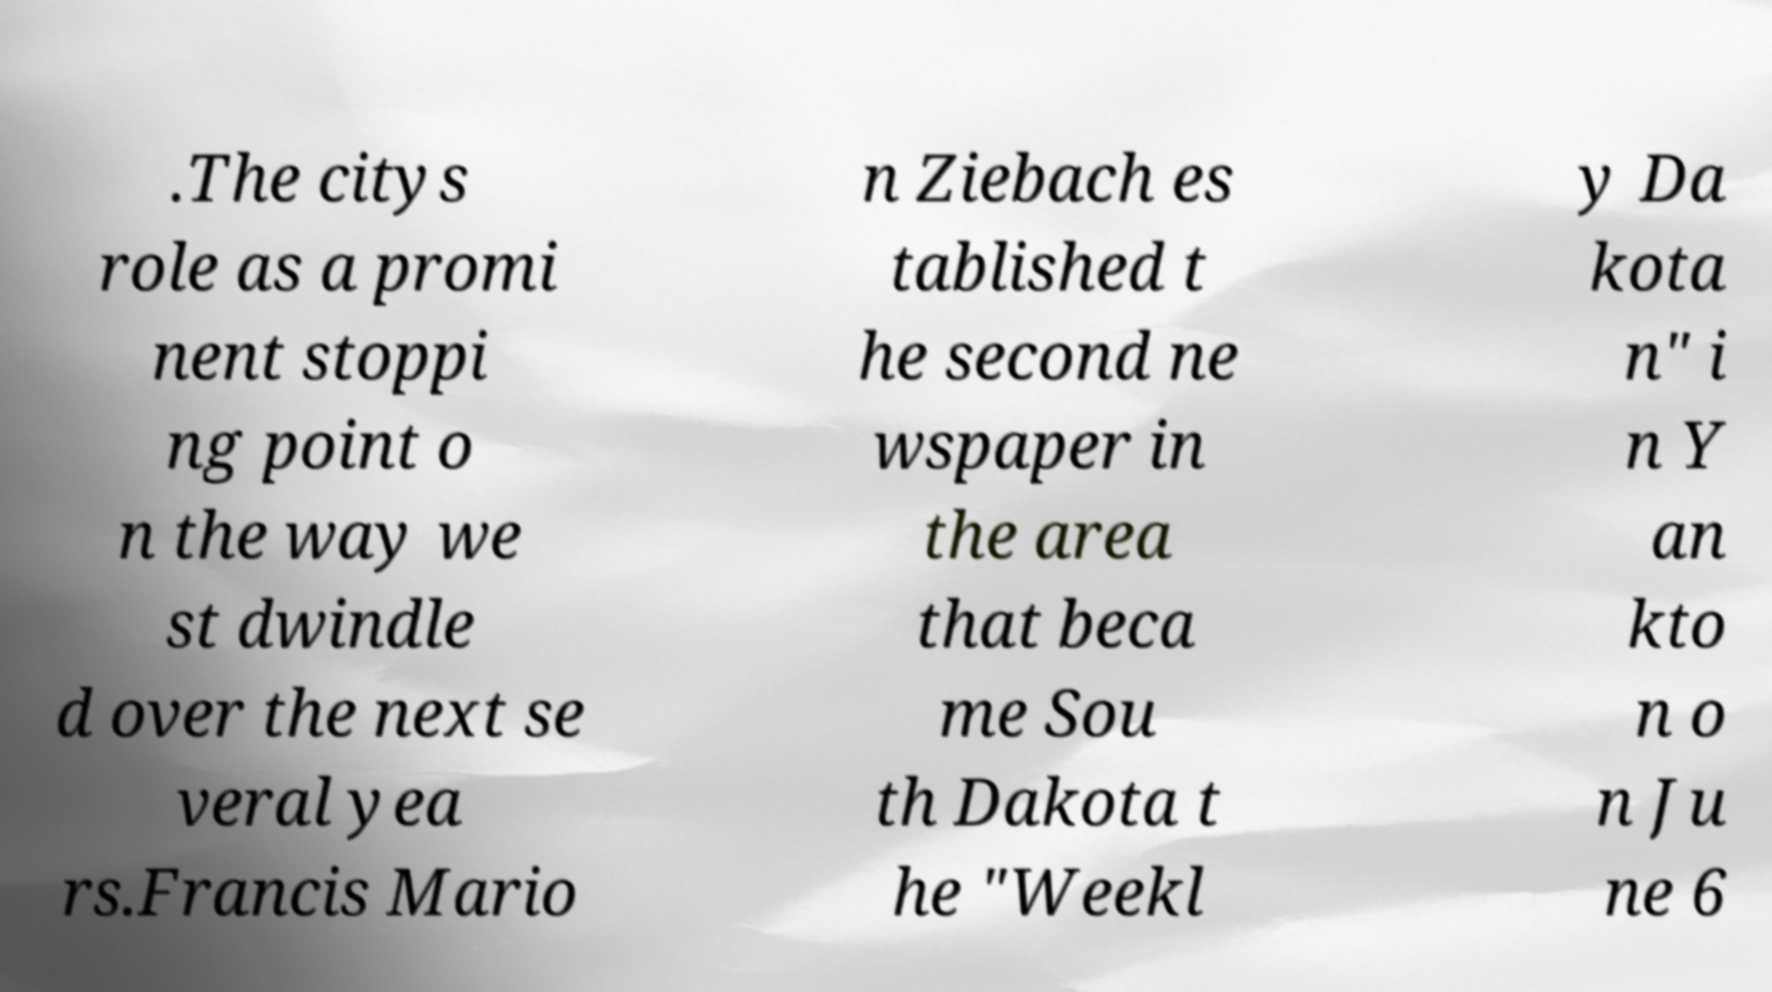Please identify and transcribe the text found in this image. .The citys role as a promi nent stoppi ng point o n the way we st dwindle d over the next se veral yea rs.Francis Mario n Ziebach es tablished t he second ne wspaper in the area that beca me Sou th Dakota t he "Weekl y Da kota n" i n Y an kto n o n Ju ne 6 